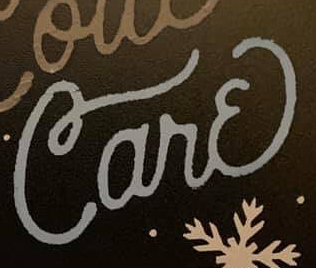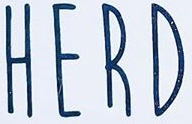Read the text content from these images in order, separated by a semicolon. Carɛ; HERD 